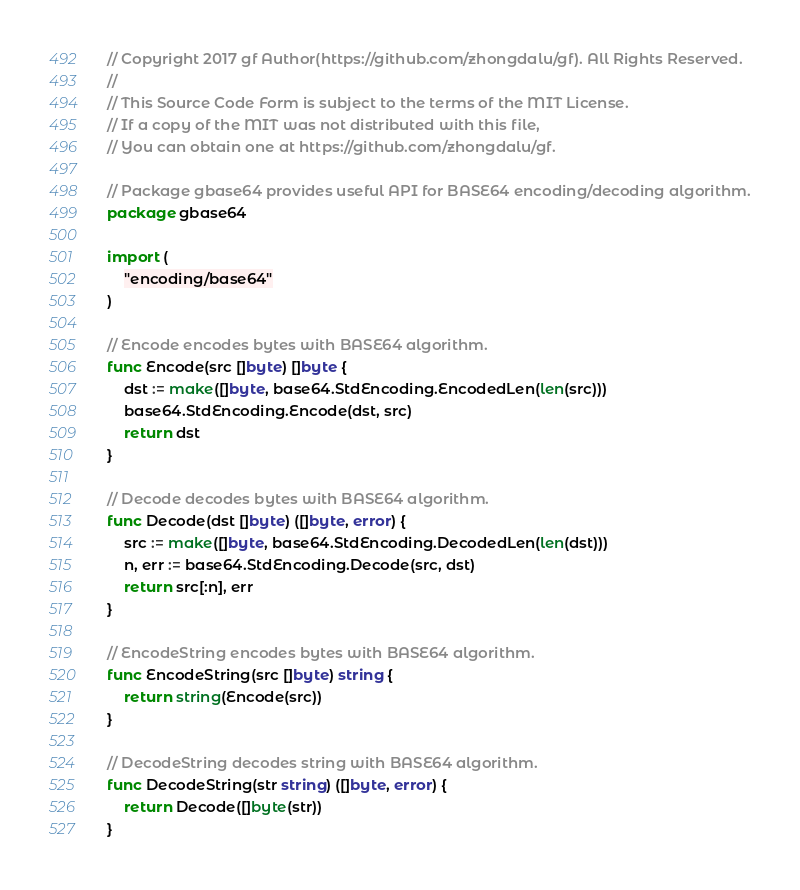Convert code to text. <code><loc_0><loc_0><loc_500><loc_500><_Go_>// Copyright 2017 gf Author(https://github.com/zhongdalu/gf). All Rights Reserved.
//
// This Source Code Form is subject to the terms of the MIT License.
// If a copy of the MIT was not distributed with this file,
// You can obtain one at https://github.com/zhongdalu/gf.

// Package gbase64 provides useful API for BASE64 encoding/decoding algorithm.
package gbase64

import (
	"encoding/base64"
)

// Encode encodes bytes with BASE64 algorithm.
func Encode(src []byte) []byte {
	dst := make([]byte, base64.StdEncoding.EncodedLen(len(src)))
	base64.StdEncoding.Encode(dst, src)
	return dst
}

// Decode decodes bytes with BASE64 algorithm.
func Decode(dst []byte) ([]byte, error) {
	src := make([]byte, base64.StdEncoding.DecodedLen(len(dst)))
	n, err := base64.StdEncoding.Decode(src, dst)
	return src[:n], err
}

// EncodeString encodes bytes with BASE64 algorithm.
func EncodeString(src []byte) string {
	return string(Encode(src))
}

// DecodeString decodes string with BASE64 algorithm.
func DecodeString(str string) ([]byte, error) {
	return Decode([]byte(str))
}
</code> 